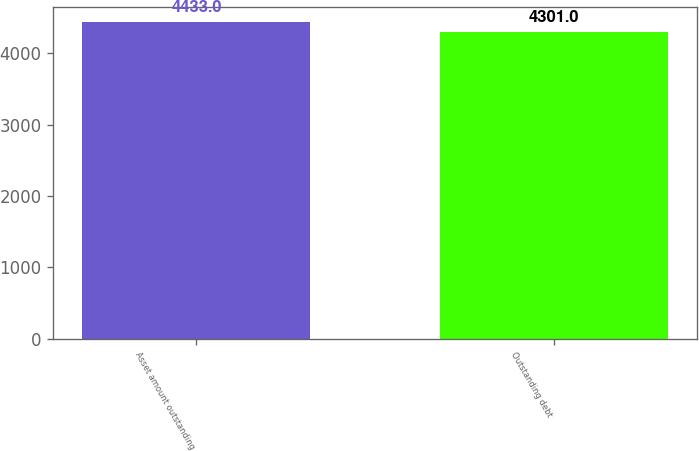Convert chart. <chart><loc_0><loc_0><loc_500><loc_500><bar_chart><fcel>Asset amount outstanding<fcel>Outstanding debt<nl><fcel>4433<fcel>4301<nl></chart> 